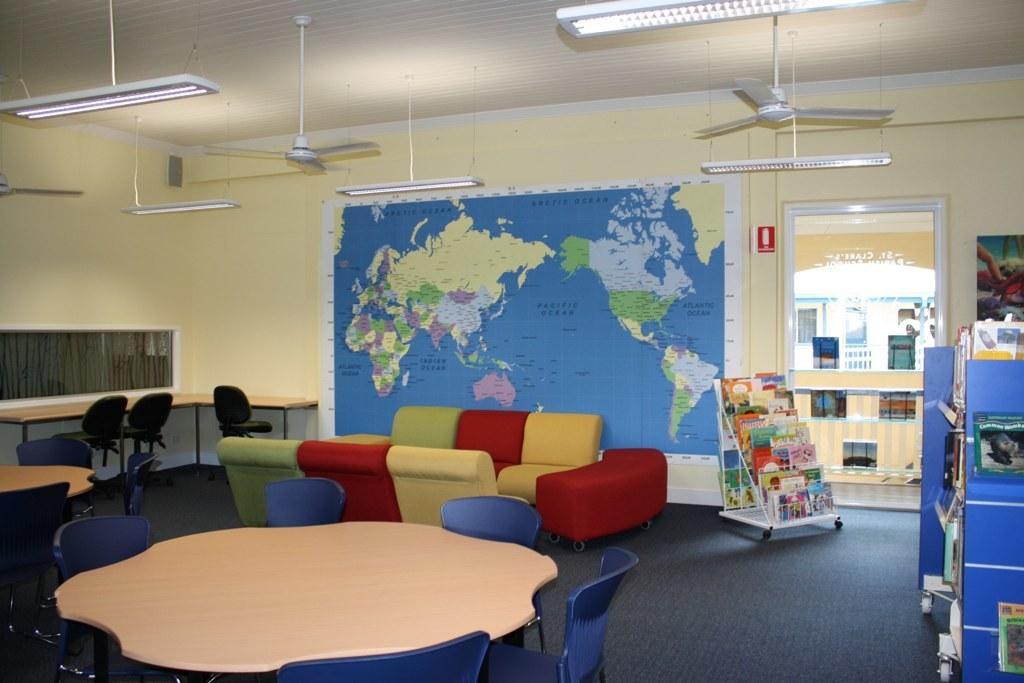How would you summarize this image in a sentence or two? At the bottom of the image there is a table with chairs. Behind them also there are few tables and chairs. And also there is a sofa. There is a wall with map and also there are windows. At the top of the image there is ceiling with lights and fans are hanging. And also there is a glass with posters and in front of the door there is a small cupboard with books. On the right corner of the image there is a cupboard with books. Behind the glass door there is an arch with wall and also there is another building. 